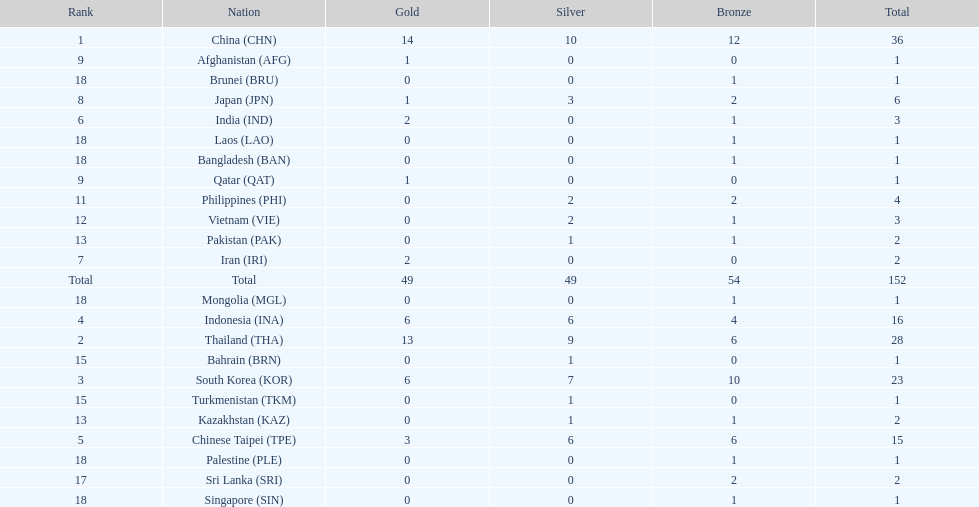How many total gold medal have been given? 49. 